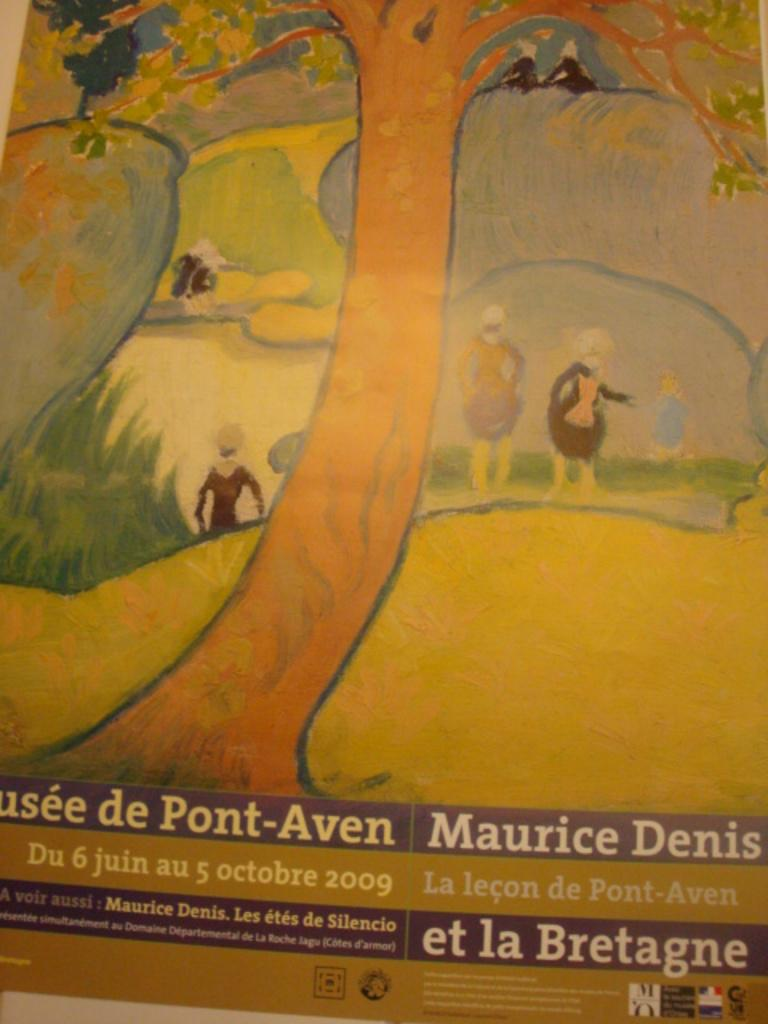Provide a one-sentence caption for the provided image. A Maurice Denis painting is depicted on a sign for a museum. 